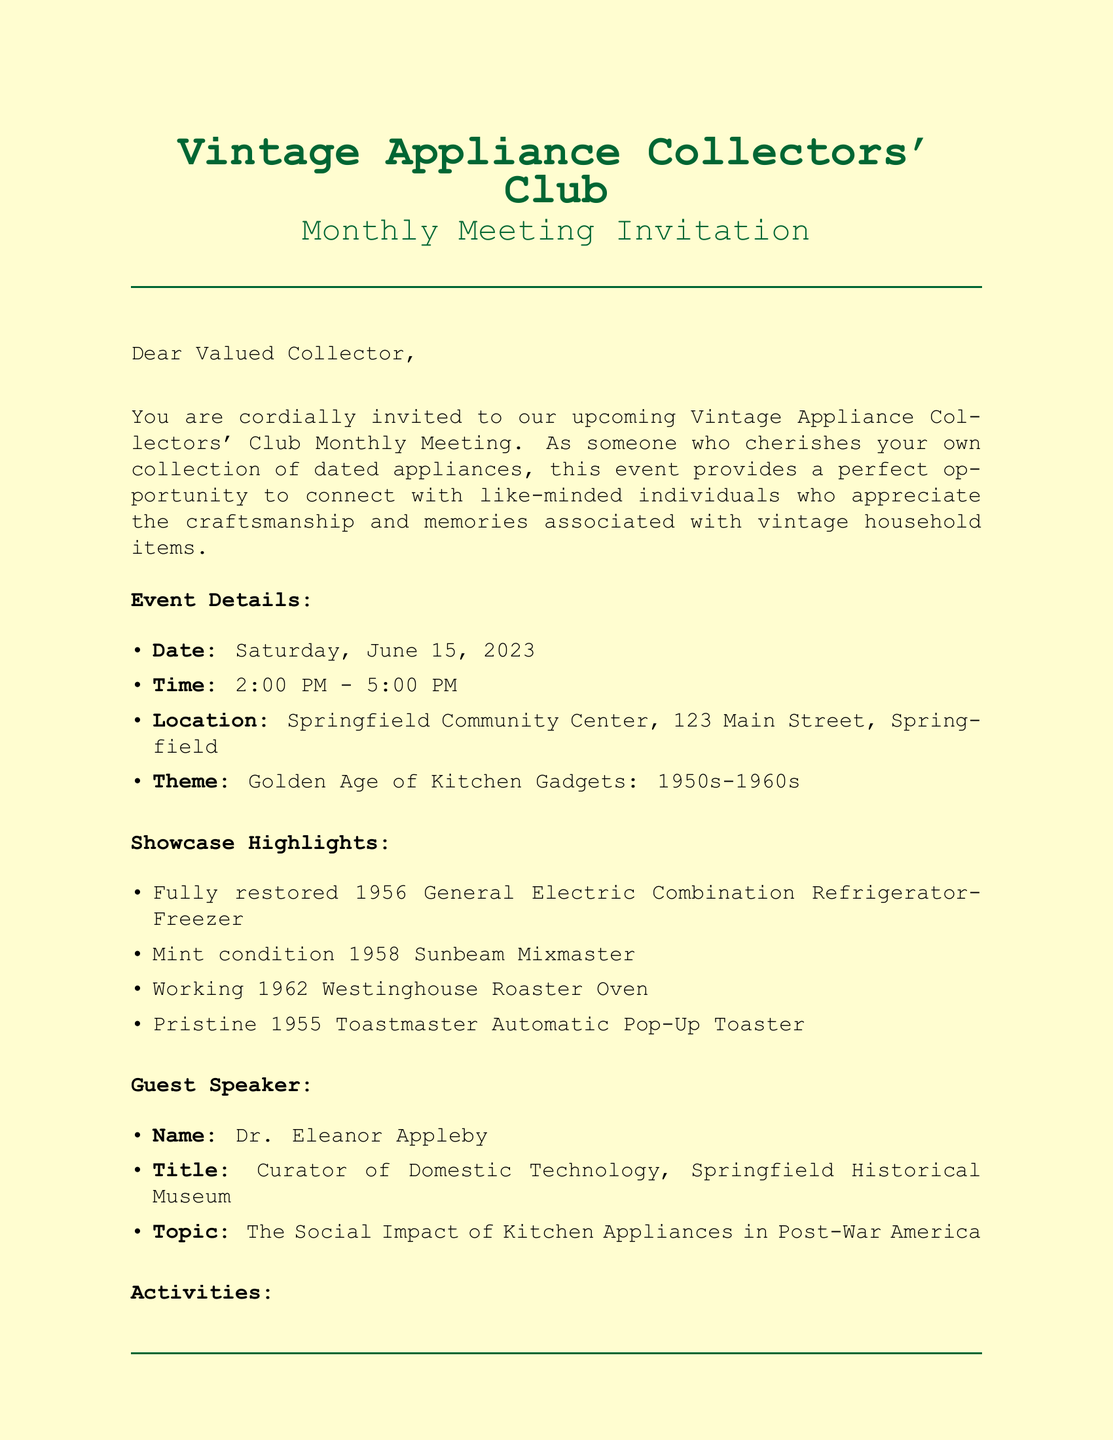What is the date of the meeting? The date of the meeting is mentioned in the event details section of the document.
Answer: Saturday, June 15, 2023 Who is the guest speaker? The guest speaker's name is listed in the guest speaker section of the document.
Answer: Dr. Eleanor Appleby What is the theme of the event? The theme of the event is specified under the event details section.
Answer: Golden Age of Kitchen Gadgets: 1950s-1960s What activity allows members to share their appliances? The activity that allows sharing among members is mentioned in the activities section.
Answer: Show-and-tell session What time does the meeting start? The start time is provided in the event details section.
Answer: 2:00 PM How much is the annual club membership? The cost of the membership is stated in the additional information section.
Answer: $25 What type of refreshments will be served? The type of refreshments is noted in the additional information section.
Answer: Light refreshments What is the RSVP deadline? The RSVP deadline is found in the RSVP information section.
Answer: June 10, 2023 What is one of the showcase highlights? One of the showcase highlights is listed in the showcase highlights section of the document.
Answer: Fully restored 1956 General Electric Combination Refrigerator-Freezer 